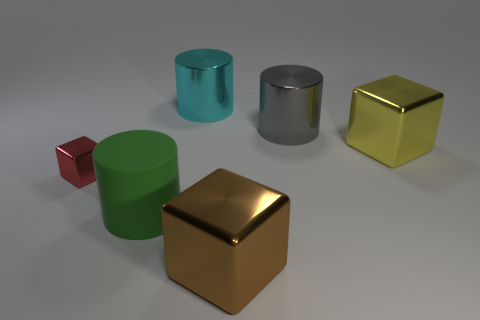Add 1 tiny red cubes. How many objects exist? 7 Subtract all tiny red metal cylinders. Subtract all big gray things. How many objects are left? 5 Add 3 big yellow metal cubes. How many big yellow metal cubes are left? 4 Add 1 cylinders. How many cylinders exist? 4 Subtract 1 gray cylinders. How many objects are left? 5 